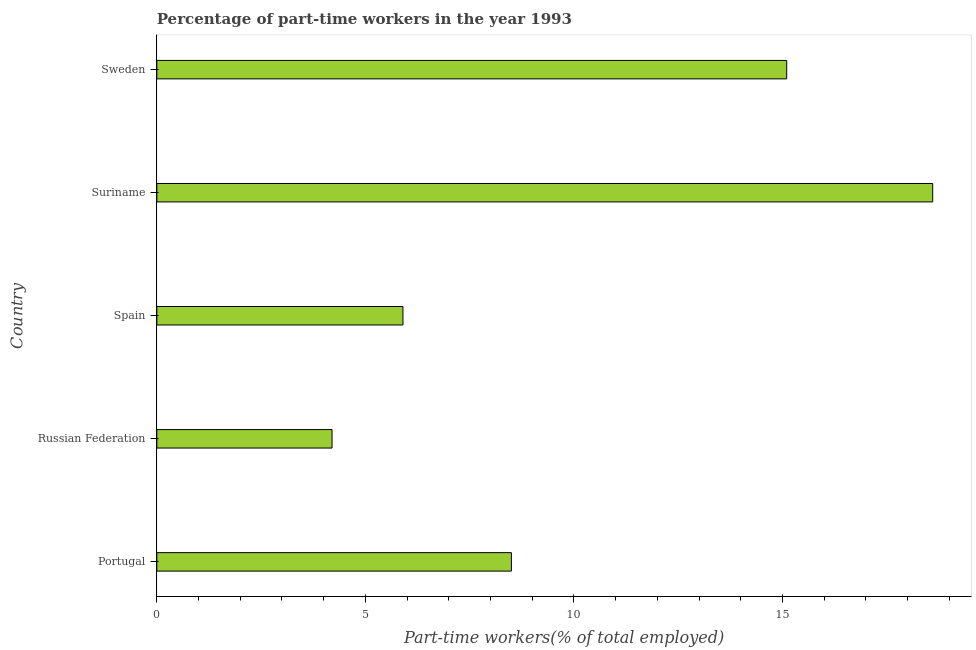Does the graph contain any zero values?
Make the answer very short. No. Does the graph contain grids?
Your response must be concise. No. What is the title of the graph?
Keep it short and to the point. Percentage of part-time workers in the year 1993. What is the label or title of the X-axis?
Provide a succinct answer. Part-time workers(% of total employed). What is the percentage of part-time workers in Spain?
Provide a succinct answer. 5.9. Across all countries, what is the maximum percentage of part-time workers?
Your answer should be very brief. 18.6. Across all countries, what is the minimum percentage of part-time workers?
Offer a terse response. 4.2. In which country was the percentage of part-time workers maximum?
Make the answer very short. Suriname. In which country was the percentage of part-time workers minimum?
Ensure brevity in your answer.  Russian Federation. What is the sum of the percentage of part-time workers?
Provide a short and direct response. 52.3. What is the difference between the percentage of part-time workers in Russian Federation and Suriname?
Your response must be concise. -14.4. What is the average percentage of part-time workers per country?
Keep it short and to the point. 10.46. What is the median percentage of part-time workers?
Keep it short and to the point. 8.5. What is the ratio of the percentage of part-time workers in Suriname to that in Sweden?
Your answer should be very brief. 1.23. Is the difference between the percentage of part-time workers in Spain and Suriname greater than the difference between any two countries?
Your response must be concise. No. Is the sum of the percentage of part-time workers in Russian Federation and Spain greater than the maximum percentage of part-time workers across all countries?
Your answer should be very brief. No. What is the difference between the highest and the lowest percentage of part-time workers?
Provide a short and direct response. 14.4. In how many countries, is the percentage of part-time workers greater than the average percentage of part-time workers taken over all countries?
Ensure brevity in your answer.  2. How many bars are there?
Give a very brief answer. 5. How many countries are there in the graph?
Offer a terse response. 5. What is the difference between two consecutive major ticks on the X-axis?
Provide a succinct answer. 5. Are the values on the major ticks of X-axis written in scientific E-notation?
Your answer should be very brief. No. What is the Part-time workers(% of total employed) in Portugal?
Your response must be concise. 8.5. What is the Part-time workers(% of total employed) in Russian Federation?
Give a very brief answer. 4.2. What is the Part-time workers(% of total employed) in Spain?
Your response must be concise. 5.9. What is the Part-time workers(% of total employed) of Suriname?
Keep it short and to the point. 18.6. What is the Part-time workers(% of total employed) of Sweden?
Your response must be concise. 15.1. What is the difference between the Part-time workers(% of total employed) in Portugal and Russian Federation?
Your answer should be very brief. 4.3. What is the difference between the Part-time workers(% of total employed) in Portugal and Suriname?
Ensure brevity in your answer.  -10.1. What is the difference between the Part-time workers(% of total employed) in Russian Federation and Suriname?
Give a very brief answer. -14.4. What is the difference between the Part-time workers(% of total employed) in Spain and Sweden?
Provide a short and direct response. -9.2. What is the difference between the Part-time workers(% of total employed) in Suriname and Sweden?
Offer a very short reply. 3.5. What is the ratio of the Part-time workers(% of total employed) in Portugal to that in Russian Federation?
Keep it short and to the point. 2.02. What is the ratio of the Part-time workers(% of total employed) in Portugal to that in Spain?
Your answer should be compact. 1.44. What is the ratio of the Part-time workers(% of total employed) in Portugal to that in Suriname?
Make the answer very short. 0.46. What is the ratio of the Part-time workers(% of total employed) in Portugal to that in Sweden?
Ensure brevity in your answer.  0.56. What is the ratio of the Part-time workers(% of total employed) in Russian Federation to that in Spain?
Provide a short and direct response. 0.71. What is the ratio of the Part-time workers(% of total employed) in Russian Federation to that in Suriname?
Give a very brief answer. 0.23. What is the ratio of the Part-time workers(% of total employed) in Russian Federation to that in Sweden?
Your response must be concise. 0.28. What is the ratio of the Part-time workers(% of total employed) in Spain to that in Suriname?
Provide a short and direct response. 0.32. What is the ratio of the Part-time workers(% of total employed) in Spain to that in Sweden?
Offer a very short reply. 0.39. What is the ratio of the Part-time workers(% of total employed) in Suriname to that in Sweden?
Ensure brevity in your answer.  1.23. 